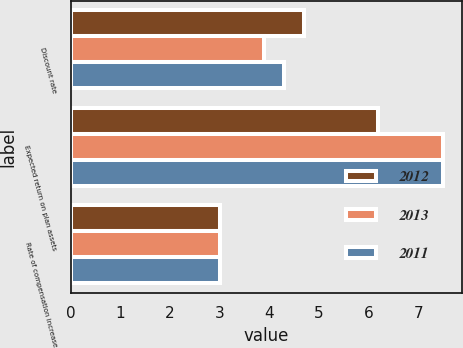Convert chart. <chart><loc_0><loc_0><loc_500><loc_500><stacked_bar_chart><ecel><fcel>Discount rate<fcel>Expected return on plan assets<fcel>Rate of compensation increase<nl><fcel>2012<fcel>4.7<fcel>6.2<fcel>3<nl><fcel>2013<fcel>3.9<fcel>7.5<fcel>3<nl><fcel>2011<fcel>4.3<fcel>7.5<fcel>3<nl></chart> 